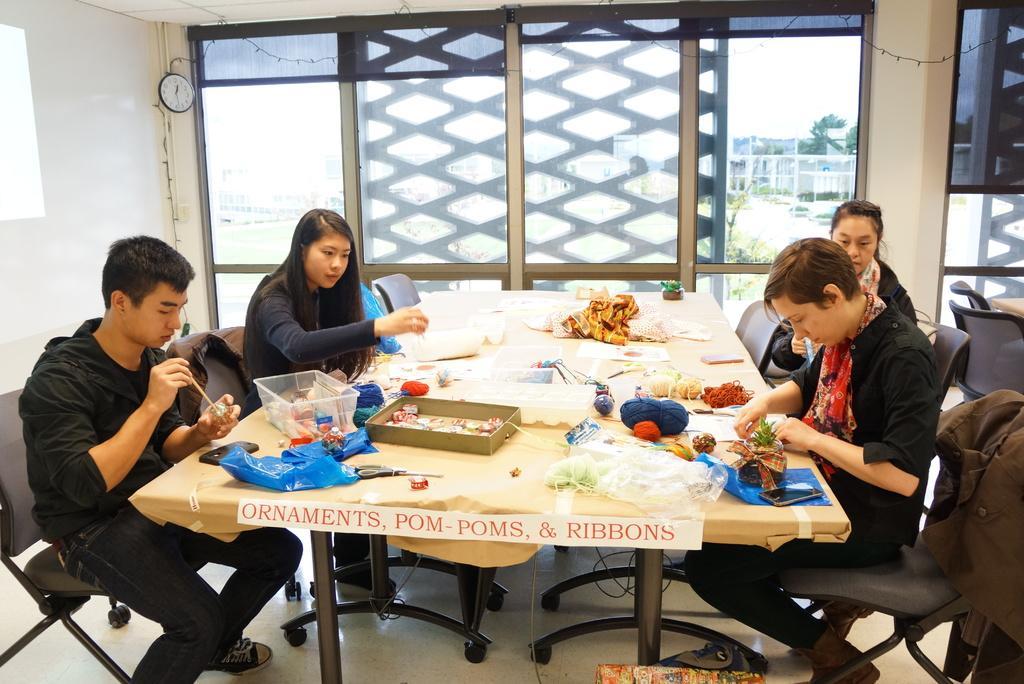Could you give a brief overview of what you see in this image? In this image i can see there are the four persons sitting around the table ,back side of them there is a window ,through the window i can see a building on the right side corner. On the left side corner a clock attached to the wall. on the table there are some objects kept on that and left side black color chairs visible. 